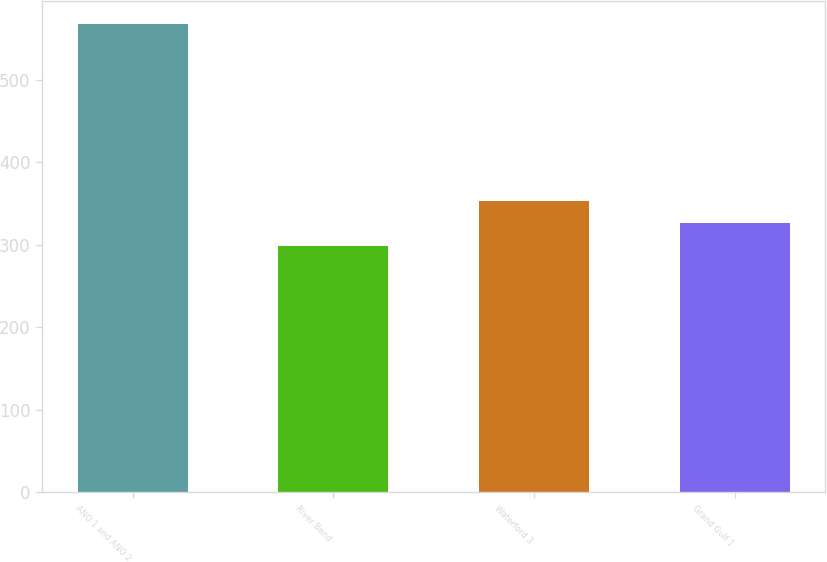Convert chart. <chart><loc_0><loc_0><loc_500><loc_500><bar_chart><fcel>ANO 1 and ANO 2<fcel>River Bend<fcel>Waterford 3<fcel>Grand Gulf 1<nl><fcel>567.5<fcel>298.8<fcel>352.54<fcel>325.67<nl></chart> 